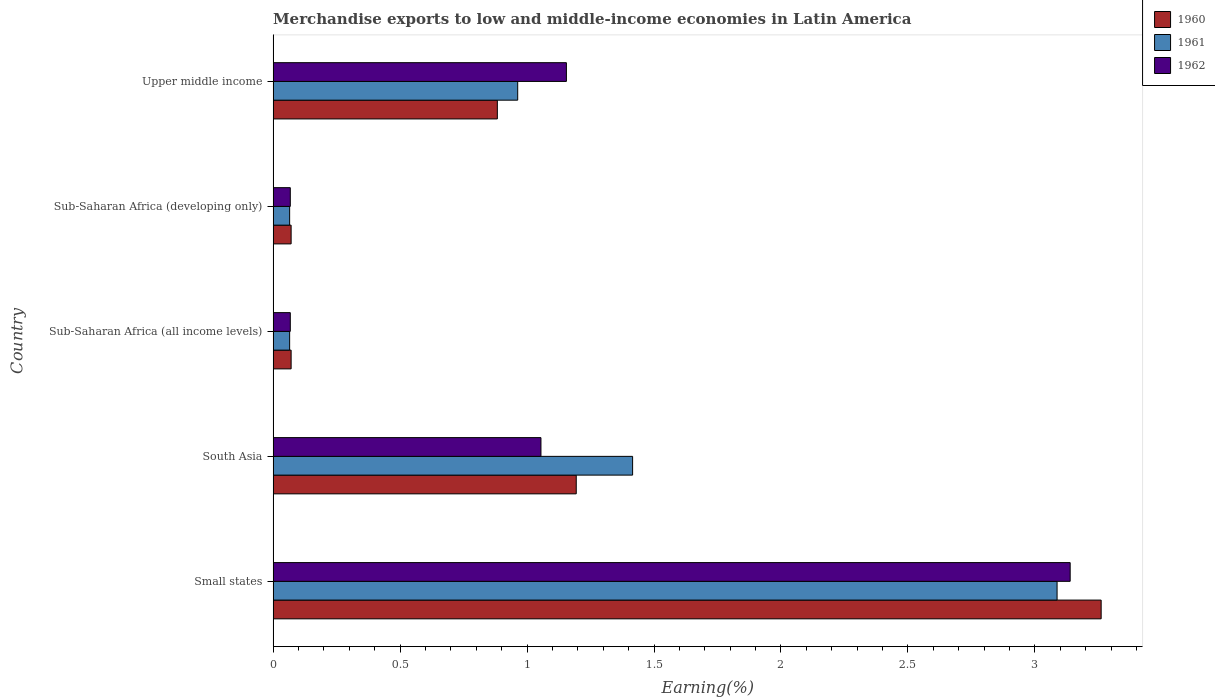How many different coloured bars are there?
Offer a terse response. 3. How many groups of bars are there?
Keep it short and to the point. 5. Are the number of bars on each tick of the Y-axis equal?
Ensure brevity in your answer.  Yes. How many bars are there on the 5th tick from the top?
Make the answer very short. 3. How many bars are there on the 1st tick from the bottom?
Make the answer very short. 3. What is the label of the 1st group of bars from the top?
Your response must be concise. Upper middle income. What is the percentage of amount earned from merchandise exports in 1961 in Small states?
Keep it short and to the point. 3.09. Across all countries, what is the maximum percentage of amount earned from merchandise exports in 1960?
Your answer should be very brief. 3.26. Across all countries, what is the minimum percentage of amount earned from merchandise exports in 1962?
Give a very brief answer. 0.07. In which country was the percentage of amount earned from merchandise exports in 1960 maximum?
Your answer should be very brief. Small states. In which country was the percentage of amount earned from merchandise exports in 1961 minimum?
Ensure brevity in your answer.  Sub-Saharan Africa (all income levels). What is the total percentage of amount earned from merchandise exports in 1960 in the graph?
Provide a short and direct response. 5.48. What is the difference between the percentage of amount earned from merchandise exports in 1960 in Small states and that in Sub-Saharan Africa (developing only)?
Your answer should be compact. 3.19. What is the difference between the percentage of amount earned from merchandise exports in 1960 in Upper middle income and the percentage of amount earned from merchandise exports in 1962 in Sub-Saharan Africa (developing only)?
Your answer should be very brief. 0.82. What is the average percentage of amount earned from merchandise exports in 1962 per country?
Make the answer very short. 1.1. What is the difference between the percentage of amount earned from merchandise exports in 1961 and percentage of amount earned from merchandise exports in 1960 in Small states?
Your answer should be very brief. -0.17. What is the ratio of the percentage of amount earned from merchandise exports in 1962 in South Asia to that in Sub-Saharan Africa (all income levels)?
Your response must be concise. 15.59. Is the percentage of amount earned from merchandise exports in 1961 in South Asia less than that in Sub-Saharan Africa (developing only)?
Ensure brevity in your answer.  No. Is the difference between the percentage of amount earned from merchandise exports in 1961 in South Asia and Upper middle income greater than the difference between the percentage of amount earned from merchandise exports in 1960 in South Asia and Upper middle income?
Offer a very short reply. Yes. What is the difference between the highest and the second highest percentage of amount earned from merchandise exports in 1961?
Give a very brief answer. 1.67. What is the difference between the highest and the lowest percentage of amount earned from merchandise exports in 1962?
Make the answer very short. 3.07. In how many countries, is the percentage of amount earned from merchandise exports in 1961 greater than the average percentage of amount earned from merchandise exports in 1961 taken over all countries?
Your answer should be very brief. 2. Is the sum of the percentage of amount earned from merchandise exports in 1962 in Sub-Saharan Africa (all income levels) and Upper middle income greater than the maximum percentage of amount earned from merchandise exports in 1960 across all countries?
Keep it short and to the point. No. What does the 1st bar from the top in South Asia represents?
Give a very brief answer. 1962. How many countries are there in the graph?
Ensure brevity in your answer.  5. What is the difference between two consecutive major ticks on the X-axis?
Your answer should be compact. 0.5. Are the values on the major ticks of X-axis written in scientific E-notation?
Your response must be concise. No. Does the graph contain any zero values?
Offer a terse response. No. How many legend labels are there?
Your answer should be compact. 3. How are the legend labels stacked?
Offer a terse response. Vertical. What is the title of the graph?
Ensure brevity in your answer.  Merchandise exports to low and middle-income economies in Latin America. Does "1999" appear as one of the legend labels in the graph?
Your response must be concise. No. What is the label or title of the X-axis?
Make the answer very short. Earning(%). What is the Earning(%) in 1960 in Small states?
Offer a terse response. 3.26. What is the Earning(%) of 1961 in Small states?
Ensure brevity in your answer.  3.09. What is the Earning(%) in 1962 in Small states?
Provide a short and direct response. 3.14. What is the Earning(%) in 1960 in South Asia?
Offer a terse response. 1.19. What is the Earning(%) in 1961 in South Asia?
Offer a terse response. 1.42. What is the Earning(%) of 1962 in South Asia?
Provide a short and direct response. 1.05. What is the Earning(%) of 1960 in Sub-Saharan Africa (all income levels)?
Your answer should be very brief. 0.07. What is the Earning(%) in 1961 in Sub-Saharan Africa (all income levels)?
Give a very brief answer. 0.07. What is the Earning(%) in 1962 in Sub-Saharan Africa (all income levels)?
Your response must be concise. 0.07. What is the Earning(%) of 1960 in Sub-Saharan Africa (developing only)?
Offer a very short reply. 0.07. What is the Earning(%) of 1961 in Sub-Saharan Africa (developing only)?
Offer a terse response. 0.07. What is the Earning(%) in 1962 in Sub-Saharan Africa (developing only)?
Provide a short and direct response. 0.07. What is the Earning(%) of 1960 in Upper middle income?
Keep it short and to the point. 0.88. What is the Earning(%) of 1961 in Upper middle income?
Offer a terse response. 0.96. What is the Earning(%) of 1962 in Upper middle income?
Offer a very short reply. 1.16. Across all countries, what is the maximum Earning(%) of 1960?
Your answer should be very brief. 3.26. Across all countries, what is the maximum Earning(%) in 1961?
Make the answer very short. 3.09. Across all countries, what is the maximum Earning(%) in 1962?
Keep it short and to the point. 3.14. Across all countries, what is the minimum Earning(%) in 1960?
Your response must be concise. 0.07. Across all countries, what is the minimum Earning(%) of 1961?
Keep it short and to the point. 0.07. Across all countries, what is the minimum Earning(%) of 1962?
Your response must be concise. 0.07. What is the total Earning(%) in 1960 in the graph?
Provide a succinct answer. 5.48. What is the total Earning(%) in 1961 in the graph?
Your response must be concise. 5.6. What is the total Earning(%) in 1962 in the graph?
Make the answer very short. 5.48. What is the difference between the Earning(%) in 1960 in Small states and that in South Asia?
Offer a terse response. 2.07. What is the difference between the Earning(%) in 1961 in Small states and that in South Asia?
Give a very brief answer. 1.67. What is the difference between the Earning(%) in 1962 in Small states and that in South Asia?
Your response must be concise. 2.08. What is the difference between the Earning(%) of 1960 in Small states and that in Sub-Saharan Africa (all income levels)?
Make the answer very short. 3.19. What is the difference between the Earning(%) in 1961 in Small states and that in Sub-Saharan Africa (all income levels)?
Provide a succinct answer. 3.02. What is the difference between the Earning(%) of 1962 in Small states and that in Sub-Saharan Africa (all income levels)?
Offer a terse response. 3.07. What is the difference between the Earning(%) in 1960 in Small states and that in Sub-Saharan Africa (developing only)?
Give a very brief answer. 3.19. What is the difference between the Earning(%) in 1961 in Small states and that in Sub-Saharan Africa (developing only)?
Offer a terse response. 3.02. What is the difference between the Earning(%) of 1962 in Small states and that in Sub-Saharan Africa (developing only)?
Provide a succinct answer. 3.07. What is the difference between the Earning(%) in 1960 in Small states and that in Upper middle income?
Your answer should be compact. 2.38. What is the difference between the Earning(%) of 1961 in Small states and that in Upper middle income?
Ensure brevity in your answer.  2.12. What is the difference between the Earning(%) in 1962 in Small states and that in Upper middle income?
Provide a short and direct response. 1.98. What is the difference between the Earning(%) of 1960 in South Asia and that in Sub-Saharan Africa (all income levels)?
Offer a very short reply. 1.12. What is the difference between the Earning(%) in 1961 in South Asia and that in Sub-Saharan Africa (all income levels)?
Your response must be concise. 1.35. What is the difference between the Earning(%) of 1962 in South Asia and that in Sub-Saharan Africa (all income levels)?
Offer a very short reply. 0.99. What is the difference between the Earning(%) of 1960 in South Asia and that in Sub-Saharan Africa (developing only)?
Provide a short and direct response. 1.12. What is the difference between the Earning(%) in 1961 in South Asia and that in Sub-Saharan Africa (developing only)?
Your answer should be compact. 1.35. What is the difference between the Earning(%) of 1962 in South Asia and that in Sub-Saharan Africa (developing only)?
Offer a very short reply. 0.99. What is the difference between the Earning(%) in 1960 in South Asia and that in Upper middle income?
Offer a terse response. 0.31. What is the difference between the Earning(%) in 1961 in South Asia and that in Upper middle income?
Offer a very short reply. 0.45. What is the difference between the Earning(%) in 1962 in South Asia and that in Upper middle income?
Your answer should be compact. -0.1. What is the difference between the Earning(%) of 1960 in Sub-Saharan Africa (all income levels) and that in Sub-Saharan Africa (developing only)?
Your answer should be compact. 0. What is the difference between the Earning(%) of 1960 in Sub-Saharan Africa (all income levels) and that in Upper middle income?
Offer a terse response. -0.81. What is the difference between the Earning(%) of 1961 in Sub-Saharan Africa (all income levels) and that in Upper middle income?
Your answer should be compact. -0.9. What is the difference between the Earning(%) of 1962 in Sub-Saharan Africa (all income levels) and that in Upper middle income?
Your answer should be very brief. -1.09. What is the difference between the Earning(%) in 1960 in Sub-Saharan Africa (developing only) and that in Upper middle income?
Your answer should be very brief. -0.81. What is the difference between the Earning(%) in 1961 in Sub-Saharan Africa (developing only) and that in Upper middle income?
Provide a succinct answer. -0.9. What is the difference between the Earning(%) in 1962 in Sub-Saharan Africa (developing only) and that in Upper middle income?
Keep it short and to the point. -1.09. What is the difference between the Earning(%) of 1960 in Small states and the Earning(%) of 1961 in South Asia?
Your answer should be very brief. 1.85. What is the difference between the Earning(%) of 1960 in Small states and the Earning(%) of 1962 in South Asia?
Your answer should be very brief. 2.21. What is the difference between the Earning(%) in 1961 in Small states and the Earning(%) in 1962 in South Asia?
Give a very brief answer. 2.03. What is the difference between the Earning(%) in 1960 in Small states and the Earning(%) in 1961 in Sub-Saharan Africa (all income levels)?
Ensure brevity in your answer.  3.2. What is the difference between the Earning(%) in 1960 in Small states and the Earning(%) in 1962 in Sub-Saharan Africa (all income levels)?
Keep it short and to the point. 3.19. What is the difference between the Earning(%) in 1961 in Small states and the Earning(%) in 1962 in Sub-Saharan Africa (all income levels)?
Keep it short and to the point. 3.02. What is the difference between the Earning(%) in 1960 in Small states and the Earning(%) in 1961 in Sub-Saharan Africa (developing only)?
Keep it short and to the point. 3.2. What is the difference between the Earning(%) in 1960 in Small states and the Earning(%) in 1962 in Sub-Saharan Africa (developing only)?
Offer a very short reply. 3.19. What is the difference between the Earning(%) of 1961 in Small states and the Earning(%) of 1962 in Sub-Saharan Africa (developing only)?
Offer a terse response. 3.02. What is the difference between the Earning(%) of 1960 in Small states and the Earning(%) of 1961 in Upper middle income?
Offer a terse response. 2.3. What is the difference between the Earning(%) in 1960 in Small states and the Earning(%) in 1962 in Upper middle income?
Provide a short and direct response. 2.11. What is the difference between the Earning(%) of 1961 in Small states and the Earning(%) of 1962 in Upper middle income?
Your answer should be compact. 1.93. What is the difference between the Earning(%) of 1960 in South Asia and the Earning(%) of 1961 in Sub-Saharan Africa (all income levels)?
Ensure brevity in your answer.  1.13. What is the difference between the Earning(%) of 1960 in South Asia and the Earning(%) of 1962 in Sub-Saharan Africa (all income levels)?
Provide a succinct answer. 1.13. What is the difference between the Earning(%) of 1961 in South Asia and the Earning(%) of 1962 in Sub-Saharan Africa (all income levels)?
Provide a succinct answer. 1.35. What is the difference between the Earning(%) of 1960 in South Asia and the Earning(%) of 1961 in Sub-Saharan Africa (developing only)?
Make the answer very short. 1.13. What is the difference between the Earning(%) of 1960 in South Asia and the Earning(%) of 1962 in Sub-Saharan Africa (developing only)?
Your answer should be very brief. 1.13. What is the difference between the Earning(%) of 1961 in South Asia and the Earning(%) of 1962 in Sub-Saharan Africa (developing only)?
Offer a very short reply. 1.35. What is the difference between the Earning(%) in 1960 in South Asia and the Earning(%) in 1961 in Upper middle income?
Offer a terse response. 0.23. What is the difference between the Earning(%) of 1960 in South Asia and the Earning(%) of 1962 in Upper middle income?
Ensure brevity in your answer.  0.04. What is the difference between the Earning(%) of 1961 in South Asia and the Earning(%) of 1962 in Upper middle income?
Your answer should be very brief. 0.26. What is the difference between the Earning(%) in 1960 in Sub-Saharan Africa (all income levels) and the Earning(%) in 1961 in Sub-Saharan Africa (developing only)?
Provide a succinct answer. 0.01. What is the difference between the Earning(%) in 1960 in Sub-Saharan Africa (all income levels) and the Earning(%) in 1962 in Sub-Saharan Africa (developing only)?
Provide a short and direct response. 0. What is the difference between the Earning(%) of 1961 in Sub-Saharan Africa (all income levels) and the Earning(%) of 1962 in Sub-Saharan Africa (developing only)?
Your response must be concise. -0. What is the difference between the Earning(%) of 1960 in Sub-Saharan Africa (all income levels) and the Earning(%) of 1961 in Upper middle income?
Your answer should be compact. -0.89. What is the difference between the Earning(%) in 1960 in Sub-Saharan Africa (all income levels) and the Earning(%) in 1962 in Upper middle income?
Give a very brief answer. -1.08. What is the difference between the Earning(%) in 1961 in Sub-Saharan Africa (all income levels) and the Earning(%) in 1962 in Upper middle income?
Ensure brevity in your answer.  -1.09. What is the difference between the Earning(%) of 1960 in Sub-Saharan Africa (developing only) and the Earning(%) of 1961 in Upper middle income?
Ensure brevity in your answer.  -0.89. What is the difference between the Earning(%) of 1960 in Sub-Saharan Africa (developing only) and the Earning(%) of 1962 in Upper middle income?
Your answer should be compact. -1.08. What is the difference between the Earning(%) of 1961 in Sub-Saharan Africa (developing only) and the Earning(%) of 1962 in Upper middle income?
Offer a very short reply. -1.09. What is the average Earning(%) in 1960 per country?
Ensure brevity in your answer.  1.1. What is the average Earning(%) in 1961 per country?
Your answer should be compact. 1.12. What is the average Earning(%) of 1962 per country?
Your answer should be compact. 1.1. What is the difference between the Earning(%) in 1960 and Earning(%) in 1961 in Small states?
Your answer should be compact. 0.17. What is the difference between the Earning(%) in 1960 and Earning(%) in 1962 in Small states?
Offer a very short reply. 0.12. What is the difference between the Earning(%) of 1961 and Earning(%) of 1962 in Small states?
Offer a very short reply. -0.05. What is the difference between the Earning(%) in 1960 and Earning(%) in 1961 in South Asia?
Give a very brief answer. -0.22. What is the difference between the Earning(%) of 1960 and Earning(%) of 1962 in South Asia?
Provide a short and direct response. 0.14. What is the difference between the Earning(%) of 1961 and Earning(%) of 1962 in South Asia?
Keep it short and to the point. 0.36. What is the difference between the Earning(%) of 1960 and Earning(%) of 1961 in Sub-Saharan Africa (all income levels)?
Offer a terse response. 0.01. What is the difference between the Earning(%) in 1960 and Earning(%) in 1962 in Sub-Saharan Africa (all income levels)?
Ensure brevity in your answer.  0. What is the difference between the Earning(%) in 1961 and Earning(%) in 1962 in Sub-Saharan Africa (all income levels)?
Ensure brevity in your answer.  -0. What is the difference between the Earning(%) in 1960 and Earning(%) in 1961 in Sub-Saharan Africa (developing only)?
Offer a terse response. 0.01. What is the difference between the Earning(%) of 1960 and Earning(%) of 1962 in Sub-Saharan Africa (developing only)?
Your answer should be very brief. 0. What is the difference between the Earning(%) of 1961 and Earning(%) of 1962 in Sub-Saharan Africa (developing only)?
Keep it short and to the point. -0. What is the difference between the Earning(%) in 1960 and Earning(%) in 1961 in Upper middle income?
Keep it short and to the point. -0.08. What is the difference between the Earning(%) of 1960 and Earning(%) of 1962 in Upper middle income?
Offer a terse response. -0.27. What is the difference between the Earning(%) of 1961 and Earning(%) of 1962 in Upper middle income?
Provide a succinct answer. -0.19. What is the ratio of the Earning(%) of 1960 in Small states to that in South Asia?
Your response must be concise. 2.73. What is the ratio of the Earning(%) of 1961 in Small states to that in South Asia?
Your answer should be compact. 2.18. What is the ratio of the Earning(%) of 1962 in Small states to that in South Asia?
Offer a terse response. 2.98. What is the ratio of the Earning(%) in 1960 in Small states to that in Sub-Saharan Africa (all income levels)?
Your response must be concise. 46. What is the ratio of the Earning(%) of 1961 in Small states to that in Sub-Saharan Africa (all income levels)?
Your answer should be compact. 47.48. What is the ratio of the Earning(%) of 1962 in Small states to that in Sub-Saharan Africa (all income levels)?
Offer a very short reply. 46.39. What is the ratio of the Earning(%) in 1960 in Small states to that in Sub-Saharan Africa (developing only)?
Give a very brief answer. 46. What is the ratio of the Earning(%) of 1961 in Small states to that in Sub-Saharan Africa (developing only)?
Ensure brevity in your answer.  47.48. What is the ratio of the Earning(%) of 1962 in Small states to that in Sub-Saharan Africa (developing only)?
Your answer should be compact. 46.39. What is the ratio of the Earning(%) in 1960 in Small states to that in Upper middle income?
Keep it short and to the point. 3.69. What is the ratio of the Earning(%) in 1961 in Small states to that in Upper middle income?
Provide a short and direct response. 3.21. What is the ratio of the Earning(%) of 1962 in Small states to that in Upper middle income?
Make the answer very short. 2.72. What is the ratio of the Earning(%) in 1960 in South Asia to that in Sub-Saharan Africa (all income levels)?
Make the answer very short. 16.84. What is the ratio of the Earning(%) of 1961 in South Asia to that in Sub-Saharan Africa (all income levels)?
Make the answer very short. 21.77. What is the ratio of the Earning(%) in 1962 in South Asia to that in Sub-Saharan Africa (all income levels)?
Provide a succinct answer. 15.59. What is the ratio of the Earning(%) in 1960 in South Asia to that in Sub-Saharan Africa (developing only)?
Offer a very short reply. 16.84. What is the ratio of the Earning(%) of 1961 in South Asia to that in Sub-Saharan Africa (developing only)?
Your answer should be compact. 21.77. What is the ratio of the Earning(%) in 1962 in South Asia to that in Sub-Saharan Africa (developing only)?
Your answer should be very brief. 15.59. What is the ratio of the Earning(%) in 1960 in South Asia to that in Upper middle income?
Your answer should be compact. 1.35. What is the ratio of the Earning(%) of 1961 in South Asia to that in Upper middle income?
Provide a succinct answer. 1.47. What is the ratio of the Earning(%) of 1962 in South Asia to that in Upper middle income?
Your answer should be very brief. 0.91. What is the ratio of the Earning(%) of 1961 in Sub-Saharan Africa (all income levels) to that in Sub-Saharan Africa (developing only)?
Ensure brevity in your answer.  1. What is the ratio of the Earning(%) of 1960 in Sub-Saharan Africa (all income levels) to that in Upper middle income?
Offer a very short reply. 0.08. What is the ratio of the Earning(%) of 1961 in Sub-Saharan Africa (all income levels) to that in Upper middle income?
Your answer should be compact. 0.07. What is the ratio of the Earning(%) of 1962 in Sub-Saharan Africa (all income levels) to that in Upper middle income?
Offer a terse response. 0.06. What is the ratio of the Earning(%) in 1960 in Sub-Saharan Africa (developing only) to that in Upper middle income?
Your answer should be compact. 0.08. What is the ratio of the Earning(%) in 1961 in Sub-Saharan Africa (developing only) to that in Upper middle income?
Make the answer very short. 0.07. What is the ratio of the Earning(%) of 1962 in Sub-Saharan Africa (developing only) to that in Upper middle income?
Keep it short and to the point. 0.06. What is the difference between the highest and the second highest Earning(%) of 1960?
Your response must be concise. 2.07. What is the difference between the highest and the second highest Earning(%) in 1961?
Ensure brevity in your answer.  1.67. What is the difference between the highest and the second highest Earning(%) of 1962?
Ensure brevity in your answer.  1.98. What is the difference between the highest and the lowest Earning(%) of 1960?
Make the answer very short. 3.19. What is the difference between the highest and the lowest Earning(%) of 1961?
Make the answer very short. 3.02. What is the difference between the highest and the lowest Earning(%) in 1962?
Your answer should be compact. 3.07. 